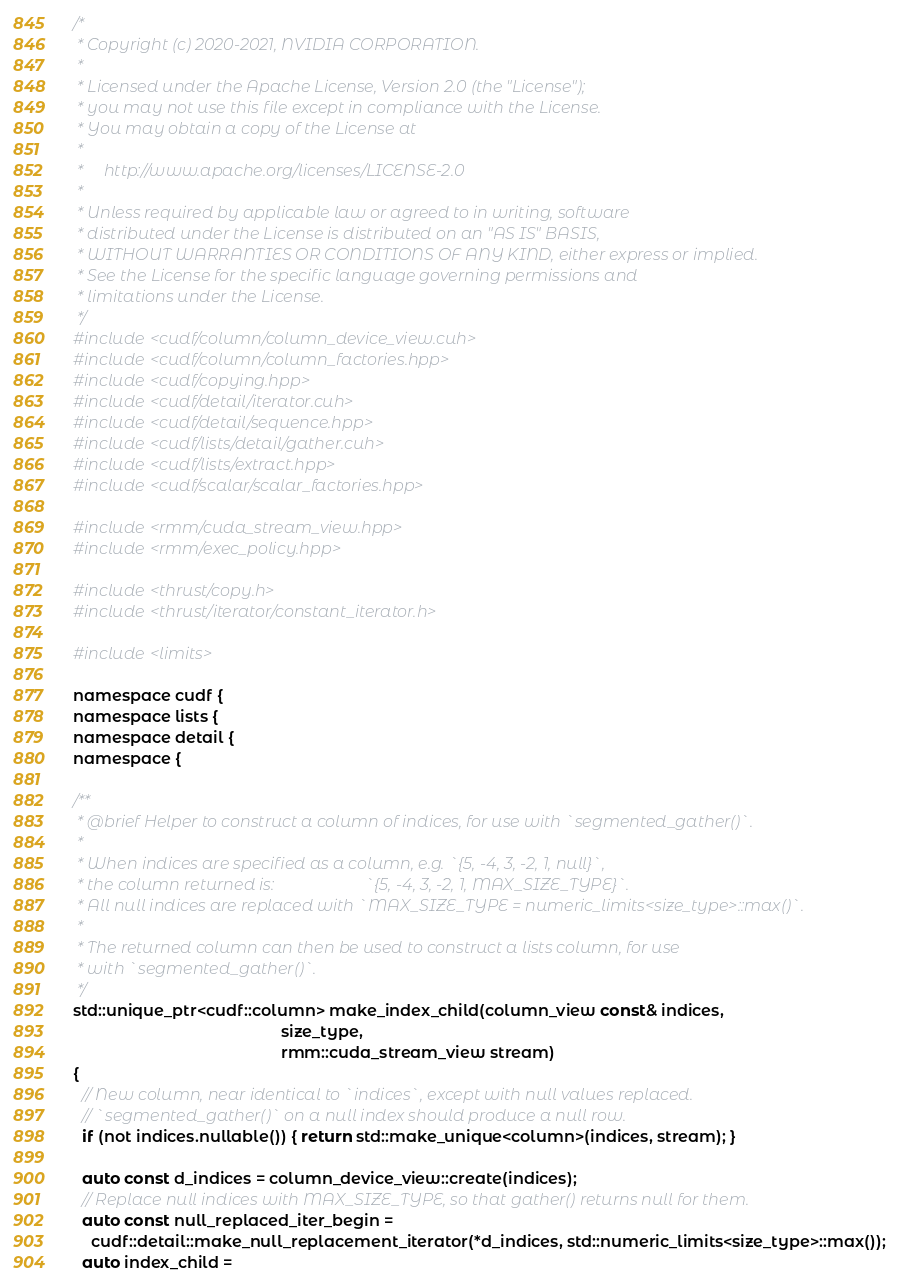<code> <loc_0><loc_0><loc_500><loc_500><_Cuda_>/*
 * Copyright (c) 2020-2021, NVIDIA CORPORATION.
 *
 * Licensed under the Apache License, Version 2.0 (the "License");
 * you may not use this file except in compliance with the License.
 * You may obtain a copy of the License at
 *
 *     http://www.apache.org/licenses/LICENSE-2.0
 *
 * Unless required by applicable law or agreed to in writing, software
 * distributed under the License is distributed on an "AS IS" BASIS,
 * WITHOUT WARRANTIES OR CONDITIONS OF ANY KIND, either express or implied.
 * See the License for the specific language governing permissions and
 * limitations under the License.
 */
#include <cudf/column/column_device_view.cuh>
#include <cudf/column/column_factories.hpp>
#include <cudf/copying.hpp>
#include <cudf/detail/iterator.cuh>
#include <cudf/detail/sequence.hpp>
#include <cudf/lists/detail/gather.cuh>
#include <cudf/lists/extract.hpp>
#include <cudf/scalar/scalar_factories.hpp>

#include <rmm/cuda_stream_view.hpp>
#include <rmm/exec_policy.hpp>

#include <thrust/copy.h>
#include <thrust/iterator/constant_iterator.h>

#include <limits>

namespace cudf {
namespace lists {
namespace detail {
namespace {

/**
 * @brief Helper to construct a column of indices, for use with `segmented_gather()`.
 *
 * When indices are specified as a column, e.g. `{5, -4, 3, -2, 1, null}`,
 * the column returned is:                      `{5, -4, 3, -2, 1, MAX_SIZE_TYPE}`.
 * All null indices are replaced with `MAX_SIZE_TYPE = numeric_limits<size_type>::max()`.
 *
 * The returned column can then be used to construct a lists column, for use
 * with `segmented_gather()`.
 */
std::unique_ptr<cudf::column> make_index_child(column_view const& indices,
                                               size_type,
                                               rmm::cuda_stream_view stream)
{
  // New column, near identical to `indices`, except with null values replaced.
  // `segmented_gather()` on a null index should produce a null row.
  if (not indices.nullable()) { return std::make_unique<column>(indices, stream); }

  auto const d_indices = column_device_view::create(indices);
  // Replace null indices with MAX_SIZE_TYPE, so that gather() returns null for them.
  auto const null_replaced_iter_begin =
    cudf::detail::make_null_replacement_iterator(*d_indices, std::numeric_limits<size_type>::max());
  auto index_child =</code> 